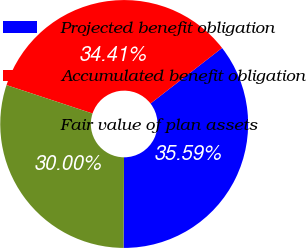Convert chart to OTSL. <chart><loc_0><loc_0><loc_500><loc_500><pie_chart><fcel>Projected benefit obligation<fcel>Accumulated benefit obligation<fcel>Fair value of plan assets<nl><fcel>35.59%<fcel>34.41%<fcel>30.0%<nl></chart> 